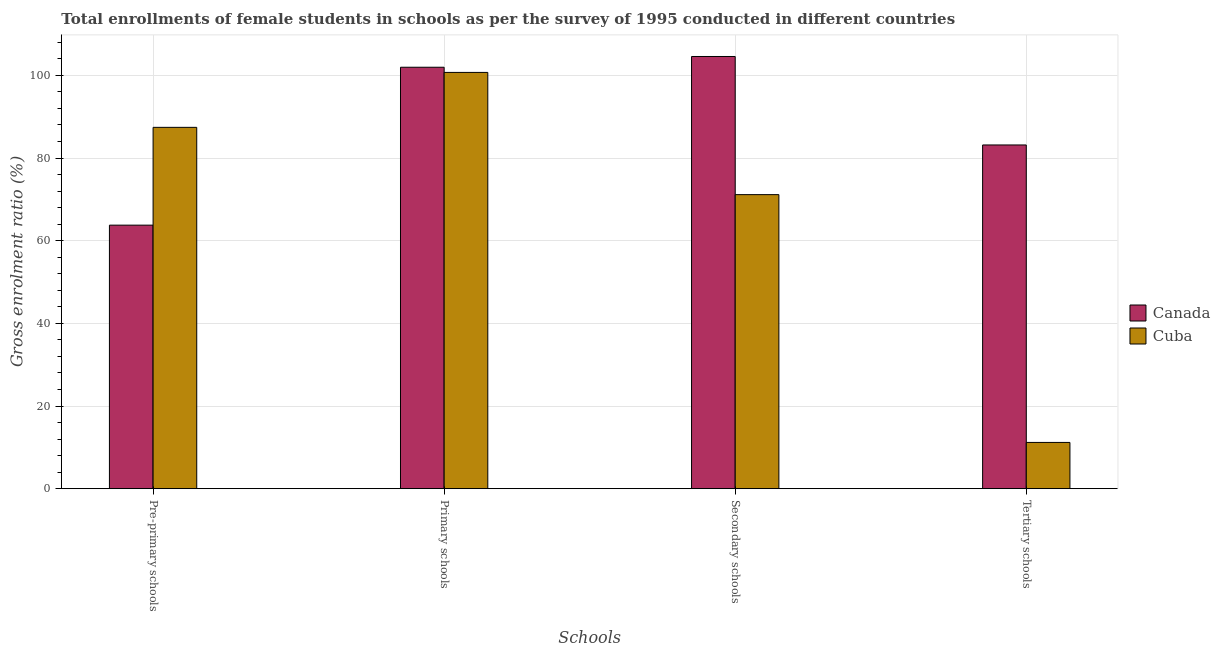Are the number of bars on each tick of the X-axis equal?
Offer a terse response. Yes. How many bars are there on the 3rd tick from the left?
Your answer should be very brief. 2. What is the label of the 3rd group of bars from the left?
Provide a succinct answer. Secondary schools. What is the gross enrolment ratio(female) in tertiary schools in Cuba?
Offer a terse response. 11.19. Across all countries, what is the maximum gross enrolment ratio(female) in pre-primary schools?
Ensure brevity in your answer.  87.41. Across all countries, what is the minimum gross enrolment ratio(female) in primary schools?
Your answer should be compact. 100.71. In which country was the gross enrolment ratio(female) in pre-primary schools minimum?
Your answer should be very brief. Canada. What is the total gross enrolment ratio(female) in primary schools in the graph?
Make the answer very short. 202.66. What is the difference between the gross enrolment ratio(female) in primary schools in Cuba and that in Canada?
Your response must be concise. -1.25. What is the difference between the gross enrolment ratio(female) in tertiary schools in Canada and the gross enrolment ratio(female) in secondary schools in Cuba?
Keep it short and to the point. 12.02. What is the average gross enrolment ratio(female) in primary schools per country?
Provide a succinct answer. 101.33. What is the difference between the gross enrolment ratio(female) in secondary schools and gross enrolment ratio(female) in primary schools in Canada?
Ensure brevity in your answer.  2.6. What is the ratio of the gross enrolment ratio(female) in secondary schools in Canada to that in Cuba?
Provide a short and direct response. 1.47. Is the gross enrolment ratio(female) in secondary schools in Cuba less than that in Canada?
Your answer should be very brief. Yes. What is the difference between the highest and the second highest gross enrolment ratio(female) in pre-primary schools?
Keep it short and to the point. 23.66. What is the difference between the highest and the lowest gross enrolment ratio(female) in secondary schools?
Give a very brief answer. 33.42. In how many countries, is the gross enrolment ratio(female) in primary schools greater than the average gross enrolment ratio(female) in primary schools taken over all countries?
Your response must be concise. 1. What does the 1st bar from the left in Tertiary schools represents?
Your answer should be compact. Canada. What does the 1st bar from the right in Secondary schools represents?
Offer a terse response. Cuba. Is it the case that in every country, the sum of the gross enrolment ratio(female) in pre-primary schools and gross enrolment ratio(female) in primary schools is greater than the gross enrolment ratio(female) in secondary schools?
Provide a succinct answer. Yes. Are all the bars in the graph horizontal?
Offer a terse response. No. How many countries are there in the graph?
Provide a succinct answer. 2. Does the graph contain grids?
Provide a succinct answer. Yes. How many legend labels are there?
Ensure brevity in your answer.  2. How are the legend labels stacked?
Give a very brief answer. Vertical. What is the title of the graph?
Keep it short and to the point. Total enrollments of female students in schools as per the survey of 1995 conducted in different countries. What is the label or title of the X-axis?
Your answer should be compact. Schools. What is the Gross enrolment ratio (%) of Canada in Pre-primary schools?
Your answer should be very brief. 63.76. What is the Gross enrolment ratio (%) in Cuba in Pre-primary schools?
Provide a short and direct response. 87.41. What is the Gross enrolment ratio (%) of Canada in Primary schools?
Offer a terse response. 101.96. What is the Gross enrolment ratio (%) of Cuba in Primary schools?
Provide a short and direct response. 100.71. What is the Gross enrolment ratio (%) in Canada in Secondary schools?
Provide a short and direct response. 104.56. What is the Gross enrolment ratio (%) in Cuba in Secondary schools?
Give a very brief answer. 71.14. What is the Gross enrolment ratio (%) of Canada in Tertiary schools?
Ensure brevity in your answer.  83.16. What is the Gross enrolment ratio (%) of Cuba in Tertiary schools?
Offer a terse response. 11.19. Across all Schools, what is the maximum Gross enrolment ratio (%) of Canada?
Make the answer very short. 104.56. Across all Schools, what is the maximum Gross enrolment ratio (%) in Cuba?
Offer a terse response. 100.71. Across all Schools, what is the minimum Gross enrolment ratio (%) in Canada?
Your answer should be compact. 63.76. Across all Schools, what is the minimum Gross enrolment ratio (%) in Cuba?
Offer a terse response. 11.19. What is the total Gross enrolment ratio (%) of Canada in the graph?
Offer a terse response. 353.43. What is the total Gross enrolment ratio (%) in Cuba in the graph?
Make the answer very short. 270.45. What is the difference between the Gross enrolment ratio (%) in Canada in Pre-primary schools and that in Primary schools?
Provide a succinct answer. -38.2. What is the difference between the Gross enrolment ratio (%) in Cuba in Pre-primary schools and that in Primary schools?
Give a very brief answer. -13.29. What is the difference between the Gross enrolment ratio (%) of Canada in Pre-primary schools and that in Secondary schools?
Provide a short and direct response. -40.8. What is the difference between the Gross enrolment ratio (%) of Cuba in Pre-primary schools and that in Secondary schools?
Keep it short and to the point. 16.28. What is the difference between the Gross enrolment ratio (%) of Canada in Pre-primary schools and that in Tertiary schools?
Provide a succinct answer. -19.4. What is the difference between the Gross enrolment ratio (%) of Cuba in Pre-primary schools and that in Tertiary schools?
Offer a very short reply. 76.22. What is the difference between the Gross enrolment ratio (%) in Canada in Primary schools and that in Secondary schools?
Keep it short and to the point. -2.6. What is the difference between the Gross enrolment ratio (%) in Cuba in Primary schools and that in Secondary schools?
Make the answer very short. 29.57. What is the difference between the Gross enrolment ratio (%) in Canada in Primary schools and that in Tertiary schools?
Ensure brevity in your answer.  18.8. What is the difference between the Gross enrolment ratio (%) in Cuba in Primary schools and that in Tertiary schools?
Your answer should be compact. 89.52. What is the difference between the Gross enrolment ratio (%) in Canada in Secondary schools and that in Tertiary schools?
Provide a succinct answer. 21.4. What is the difference between the Gross enrolment ratio (%) of Cuba in Secondary schools and that in Tertiary schools?
Your answer should be very brief. 59.95. What is the difference between the Gross enrolment ratio (%) of Canada in Pre-primary schools and the Gross enrolment ratio (%) of Cuba in Primary schools?
Keep it short and to the point. -36.95. What is the difference between the Gross enrolment ratio (%) of Canada in Pre-primary schools and the Gross enrolment ratio (%) of Cuba in Secondary schools?
Offer a very short reply. -7.38. What is the difference between the Gross enrolment ratio (%) in Canada in Pre-primary schools and the Gross enrolment ratio (%) in Cuba in Tertiary schools?
Offer a terse response. 52.57. What is the difference between the Gross enrolment ratio (%) in Canada in Primary schools and the Gross enrolment ratio (%) in Cuba in Secondary schools?
Provide a succinct answer. 30.82. What is the difference between the Gross enrolment ratio (%) in Canada in Primary schools and the Gross enrolment ratio (%) in Cuba in Tertiary schools?
Your answer should be very brief. 90.77. What is the difference between the Gross enrolment ratio (%) of Canada in Secondary schools and the Gross enrolment ratio (%) of Cuba in Tertiary schools?
Keep it short and to the point. 93.37. What is the average Gross enrolment ratio (%) in Canada per Schools?
Provide a short and direct response. 88.36. What is the average Gross enrolment ratio (%) of Cuba per Schools?
Provide a short and direct response. 67.61. What is the difference between the Gross enrolment ratio (%) of Canada and Gross enrolment ratio (%) of Cuba in Pre-primary schools?
Make the answer very short. -23.66. What is the difference between the Gross enrolment ratio (%) of Canada and Gross enrolment ratio (%) of Cuba in Primary schools?
Provide a short and direct response. 1.25. What is the difference between the Gross enrolment ratio (%) in Canada and Gross enrolment ratio (%) in Cuba in Secondary schools?
Offer a terse response. 33.42. What is the difference between the Gross enrolment ratio (%) of Canada and Gross enrolment ratio (%) of Cuba in Tertiary schools?
Your answer should be compact. 71.97. What is the ratio of the Gross enrolment ratio (%) in Canada in Pre-primary schools to that in Primary schools?
Your answer should be compact. 0.63. What is the ratio of the Gross enrolment ratio (%) of Cuba in Pre-primary schools to that in Primary schools?
Your answer should be compact. 0.87. What is the ratio of the Gross enrolment ratio (%) of Canada in Pre-primary schools to that in Secondary schools?
Offer a terse response. 0.61. What is the ratio of the Gross enrolment ratio (%) of Cuba in Pre-primary schools to that in Secondary schools?
Keep it short and to the point. 1.23. What is the ratio of the Gross enrolment ratio (%) of Canada in Pre-primary schools to that in Tertiary schools?
Provide a short and direct response. 0.77. What is the ratio of the Gross enrolment ratio (%) in Cuba in Pre-primary schools to that in Tertiary schools?
Your answer should be very brief. 7.81. What is the ratio of the Gross enrolment ratio (%) in Canada in Primary schools to that in Secondary schools?
Offer a very short reply. 0.98. What is the ratio of the Gross enrolment ratio (%) in Cuba in Primary schools to that in Secondary schools?
Keep it short and to the point. 1.42. What is the ratio of the Gross enrolment ratio (%) in Canada in Primary schools to that in Tertiary schools?
Provide a short and direct response. 1.23. What is the ratio of the Gross enrolment ratio (%) of Cuba in Primary schools to that in Tertiary schools?
Make the answer very short. 9. What is the ratio of the Gross enrolment ratio (%) in Canada in Secondary schools to that in Tertiary schools?
Provide a succinct answer. 1.26. What is the ratio of the Gross enrolment ratio (%) in Cuba in Secondary schools to that in Tertiary schools?
Your response must be concise. 6.36. What is the difference between the highest and the second highest Gross enrolment ratio (%) of Canada?
Give a very brief answer. 2.6. What is the difference between the highest and the second highest Gross enrolment ratio (%) of Cuba?
Keep it short and to the point. 13.29. What is the difference between the highest and the lowest Gross enrolment ratio (%) of Canada?
Your response must be concise. 40.8. What is the difference between the highest and the lowest Gross enrolment ratio (%) of Cuba?
Provide a succinct answer. 89.52. 